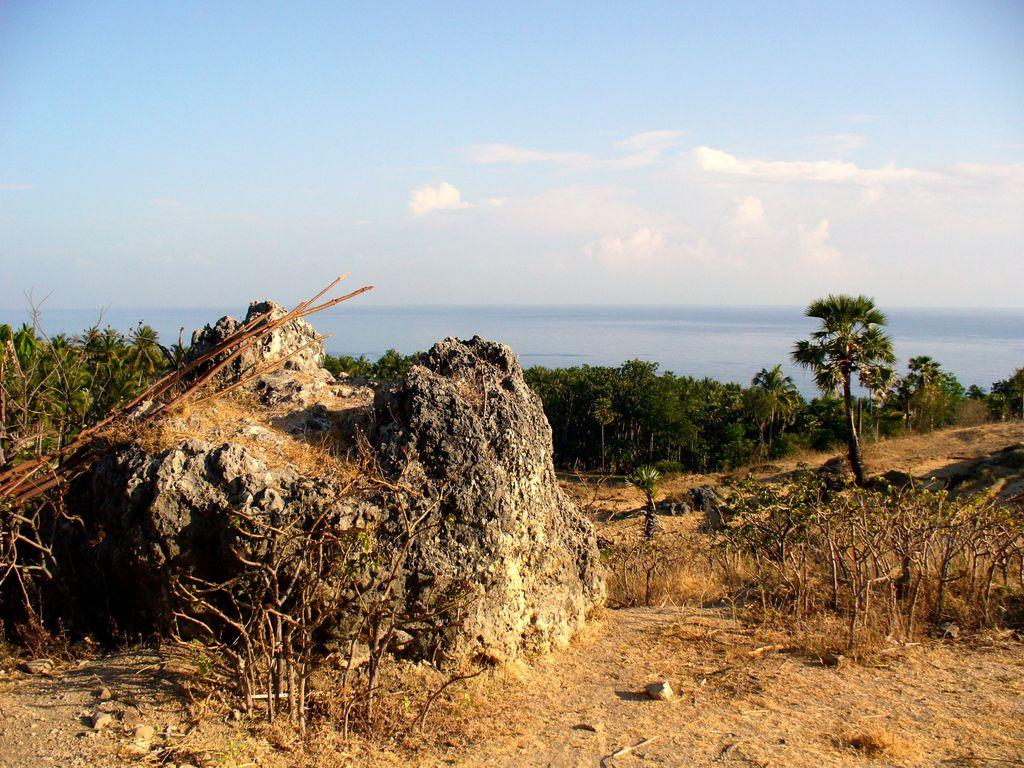What is the main subject in the image? There is a rock in the image. What is located behind the rock? There are plants behind the rock. What is located behind the plants? There are trees behind the plants. What is visible in the background of the image? The sky is visible in the image, and there is a sea visible behind the trees. What type of treatment is being administered to the nation in the image? There is no reference to a nation or any treatment in the image; it features a rock, plants, trees, sky, and sea. 